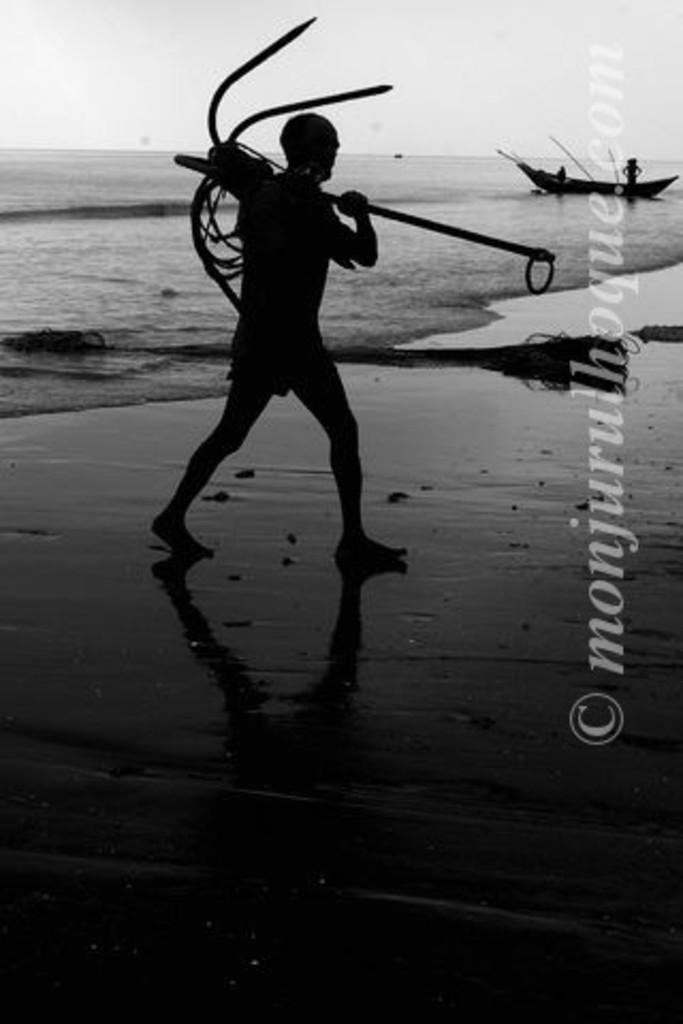<image>
Relay a brief, clear account of the picture shown. A black and white photo with the copyright monjurulhoque.com. 